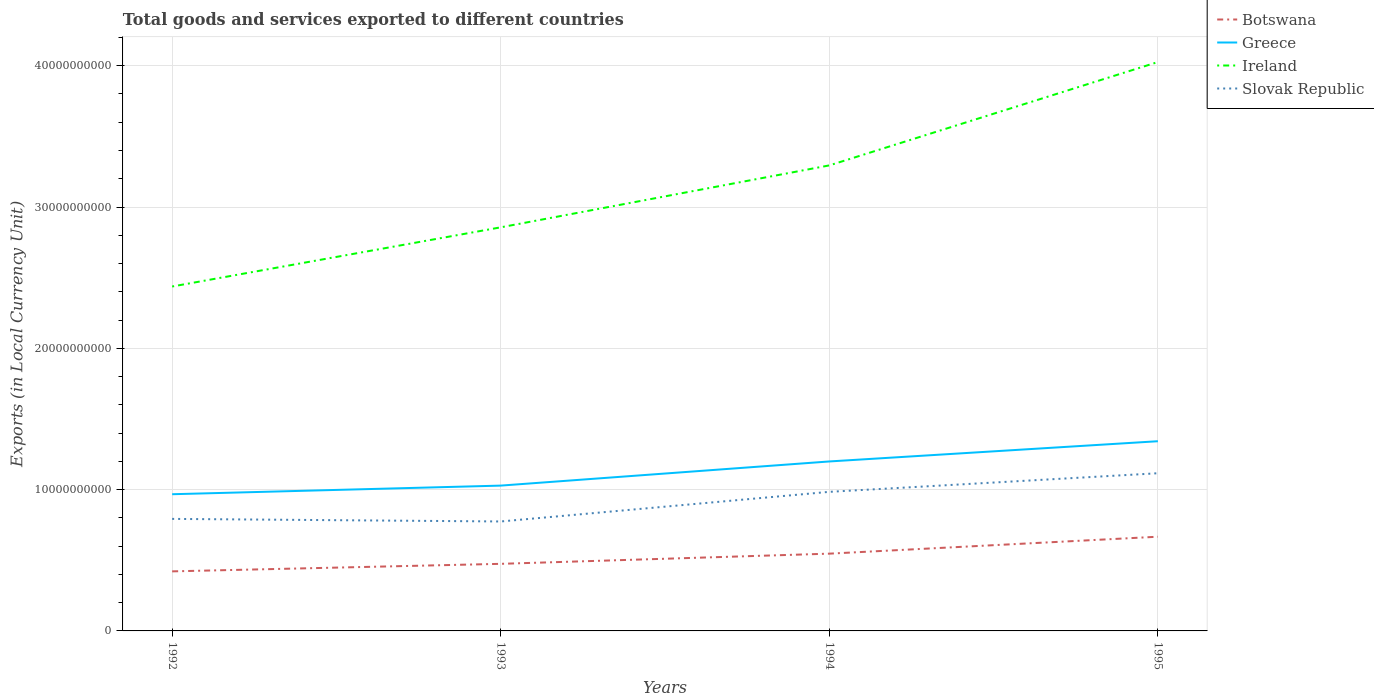Does the line corresponding to Greece intersect with the line corresponding to Slovak Republic?
Offer a very short reply. No. Is the number of lines equal to the number of legend labels?
Provide a succinct answer. Yes. Across all years, what is the maximum Amount of goods and services exports in Ireland?
Offer a very short reply. 2.44e+1. In which year was the Amount of goods and services exports in Ireland maximum?
Your response must be concise. 1992. What is the total Amount of goods and services exports in Ireland in the graph?
Your answer should be compact. -7.31e+09. What is the difference between the highest and the second highest Amount of goods and services exports in Ireland?
Make the answer very short. 1.59e+1. How many lines are there?
Give a very brief answer. 4. What is the difference between two consecutive major ticks on the Y-axis?
Offer a terse response. 1.00e+1. Are the values on the major ticks of Y-axis written in scientific E-notation?
Your answer should be very brief. No. Does the graph contain any zero values?
Your answer should be very brief. No. Where does the legend appear in the graph?
Offer a terse response. Top right. How many legend labels are there?
Offer a very short reply. 4. How are the legend labels stacked?
Offer a very short reply. Vertical. What is the title of the graph?
Offer a terse response. Total goods and services exported to different countries. What is the label or title of the X-axis?
Provide a succinct answer. Years. What is the label or title of the Y-axis?
Your answer should be compact. Exports (in Local Currency Unit). What is the Exports (in Local Currency Unit) in Botswana in 1992?
Provide a succinct answer. 4.21e+09. What is the Exports (in Local Currency Unit) in Greece in 1992?
Provide a short and direct response. 9.67e+09. What is the Exports (in Local Currency Unit) in Ireland in 1992?
Make the answer very short. 2.44e+1. What is the Exports (in Local Currency Unit) of Slovak Republic in 1992?
Provide a succinct answer. 7.93e+09. What is the Exports (in Local Currency Unit) of Botswana in 1993?
Offer a terse response. 4.75e+09. What is the Exports (in Local Currency Unit) of Greece in 1993?
Offer a very short reply. 1.03e+1. What is the Exports (in Local Currency Unit) in Ireland in 1993?
Ensure brevity in your answer.  2.86e+1. What is the Exports (in Local Currency Unit) in Slovak Republic in 1993?
Provide a short and direct response. 7.75e+09. What is the Exports (in Local Currency Unit) of Botswana in 1994?
Your response must be concise. 5.47e+09. What is the Exports (in Local Currency Unit) of Greece in 1994?
Your response must be concise. 1.20e+1. What is the Exports (in Local Currency Unit) in Ireland in 1994?
Your response must be concise. 3.29e+1. What is the Exports (in Local Currency Unit) of Slovak Republic in 1994?
Keep it short and to the point. 9.84e+09. What is the Exports (in Local Currency Unit) of Botswana in 1995?
Offer a very short reply. 6.67e+09. What is the Exports (in Local Currency Unit) of Greece in 1995?
Ensure brevity in your answer.  1.34e+1. What is the Exports (in Local Currency Unit) of Ireland in 1995?
Provide a short and direct response. 4.03e+1. What is the Exports (in Local Currency Unit) in Slovak Republic in 1995?
Your response must be concise. 1.12e+1. Across all years, what is the maximum Exports (in Local Currency Unit) in Botswana?
Ensure brevity in your answer.  6.67e+09. Across all years, what is the maximum Exports (in Local Currency Unit) of Greece?
Provide a short and direct response. 1.34e+1. Across all years, what is the maximum Exports (in Local Currency Unit) of Ireland?
Keep it short and to the point. 4.03e+1. Across all years, what is the maximum Exports (in Local Currency Unit) of Slovak Republic?
Your response must be concise. 1.12e+1. Across all years, what is the minimum Exports (in Local Currency Unit) in Botswana?
Make the answer very short. 4.21e+09. Across all years, what is the minimum Exports (in Local Currency Unit) of Greece?
Provide a succinct answer. 9.67e+09. Across all years, what is the minimum Exports (in Local Currency Unit) in Ireland?
Keep it short and to the point. 2.44e+1. Across all years, what is the minimum Exports (in Local Currency Unit) in Slovak Republic?
Keep it short and to the point. 7.75e+09. What is the total Exports (in Local Currency Unit) in Botswana in the graph?
Ensure brevity in your answer.  2.11e+1. What is the total Exports (in Local Currency Unit) in Greece in the graph?
Your answer should be compact. 4.54e+1. What is the total Exports (in Local Currency Unit) of Ireland in the graph?
Your answer should be very brief. 1.26e+11. What is the total Exports (in Local Currency Unit) in Slovak Republic in the graph?
Your response must be concise. 3.67e+1. What is the difference between the Exports (in Local Currency Unit) of Botswana in 1992 and that in 1993?
Your answer should be very brief. -5.33e+08. What is the difference between the Exports (in Local Currency Unit) in Greece in 1992 and that in 1993?
Provide a succinct answer. -6.10e+08. What is the difference between the Exports (in Local Currency Unit) in Ireland in 1992 and that in 1993?
Your answer should be very brief. -4.19e+09. What is the difference between the Exports (in Local Currency Unit) of Slovak Republic in 1992 and that in 1993?
Your answer should be compact. 1.83e+08. What is the difference between the Exports (in Local Currency Unit) of Botswana in 1992 and that in 1994?
Your answer should be very brief. -1.25e+09. What is the difference between the Exports (in Local Currency Unit) of Greece in 1992 and that in 1994?
Keep it short and to the point. -2.32e+09. What is the difference between the Exports (in Local Currency Unit) in Ireland in 1992 and that in 1994?
Offer a very short reply. -8.57e+09. What is the difference between the Exports (in Local Currency Unit) in Slovak Republic in 1992 and that in 1994?
Provide a short and direct response. -1.91e+09. What is the difference between the Exports (in Local Currency Unit) of Botswana in 1992 and that in 1995?
Give a very brief answer. -2.45e+09. What is the difference between the Exports (in Local Currency Unit) in Greece in 1992 and that in 1995?
Provide a short and direct response. -3.75e+09. What is the difference between the Exports (in Local Currency Unit) in Ireland in 1992 and that in 1995?
Ensure brevity in your answer.  -1.59e+1. What is the difference between the Exports (in Local Currency Unit) of Slovak Republic in 1992 and that in 1995?
Your response must be concise. -3.23e+09. What is the difference between the Exports (in Local Currency Unit) in Botswana in 1993 and that in 1994?
Offer a very short reply. -7.21e+08. What is the difference between the Exports (in Local Currency Unit) of Greece in 1993 and that in 1994?
Make the answer very short. -1.71e+09. What is the difference between the Exports (in Local Currency Unit) in Ireland in 1993 and that in 1994?
Your response must be concise. -4.38e+09. What is the difference between the Exports (in Local Currency Unit) of Slovak Republic in 1993 and that in 1994?
Your response must be concise. -2.10e+09. What is the difference between the Exports (in Local Currency Unit) of Botswana in 1993 and that in 1995?
Offer a terse response. -1.92e+09. What is the difference between the Exports (in Local Currency Unit) in Greece in 1993 and that in 1995?
Provide a succinct answer. -3.14e+09. What is the difference between the Exports (in Local Currency Unit) of Ireland in 1993 and that in 1995?
Your answer should be compact. -1.17e+1. What is the difference between the Exports (in Local Currency Unit) of Slovak Republic in 1993 and that in 1995?
Make the answer very short. -3.41e+09. What is the difference between the Exports (in Local Currency Unit) in Botswana in 1994 and that in 1995?
Provide a succinct answer. -1.20e+09. What is the difference between the Exports (in Local Currency Unit) in Greece in 1994 and that in 1995?
Your answer should be very brief. -1.43e+09. What is the difference between the Exports (in Local Currency Unit) of Ireland in 1994 and that in 1995?
Keep it short and to the point. -7.31e+09. What is the difference between the Exports (in Local Currency Unit) in Slovak Republic in 1994 and that in 1995?
Provide a succinct answer. -1.32e+09. What is the difference between the Exports (in Local Currency Unit) in Botswana in 1992 and the Exports (in Local Currency Unit) in Greece in 1993?
Ensure brevity in your answer.  -6.07e+09. What is the difference between the Exports (in Local Currency Unit) of Botswana in 1992 and the Exports (in Local Currency Unit) of Ireland in 1993?
Provide a short and direct response. -2.43e+1. What is the difference between the Exports (in Local Currency Unit) of Botswana in 1992 and the Exports (in Local Currency Unit) of Slovak Republic in 1993?
Your response must be concise. -3.53e+09. What is the difference between the Exports (in Local Currency Unit) of Greece in 1992 and the Exports (in Local Currency Unit) of Ireland in 1993?
Give a very brief answer. -1.89e+1. What is the difference between the Exports (in Local Currency Unit) of Greece in 1992 and the Exports (in Local Currency Unit) of Slovak Republic in 1993?
Keep it short and to the point. 1.93e+09. What is the difference between the Exports (in Local Currency Unit) of Ireland in 1992 and the Exports (in Local Currency Unit) of Slovak Republic in 1993?
Your response must be concise. 1.66e+1. What is the difference between the Exports (in Local Currency Unit) of Botswana in 1992 and the Exports (in Local Currency Unit) of Greece in 1994?
Ensure brevity in your answer.  -7.78e+09. What is the difference between the Exports (in Local Currency Unit) of Botswana in 1992 and the Exports (in Local Currency Unit) of Ireland in 1994?
Your response must be concise. -2.87e+1. What is the difference between the Exports (in Local Currency Unit) in Botswana in 1992 and the Exports (in Local Currency Unit) in Slovak Republic in 1994?
Provide a succinct answer. -5.63e+09. What is the difference between the Exports (in Local Currency Unit) in Greece in 1992 and the Exports (in Local Currency Unit) in Ireland in 1994?
Offer a very short reply. -2.33e+1. What is the difference between the Exports (in Local Currency Unit) of Greece in 1992 and the Exports (in Local Currency Unit) of Slovak Republic in 1994?
Your answer should be very brief. -1.69e+08. What is the difference between the Exports (in Local Currency Unit) of Ireland in 1992 and the Exports (in Local Currency Unit) of Slovak Republic in 1994?
Make the answer very short. 1.45e+1. What is the difference between the Exports (in Local Currency Unit) of Botswana in 1992 and the Exports (in Local Currency Unit) of Greece in 1995?
Provide a short and direct response. -9.21e+09. What is the difference between the Exports (in Local Currency Unit) in Botswana in 1992 and the Exports (in Local Currency Unit) in Ireland in 1995?
Give a very brief answer. -3.60e+1. What is the difference between the Exports (in Local Currency Unit) in Botswana in 1992 and the Exports (in Local Currency Unit) in Slovak Republic in 1995?
Offer a very short reply. -6.94e+09. What is the difference between the Exports (in Local Currency Unit) in Greece in 1992 and the Exports (in Local Currency Unit) in Ireland in 1995?
Ensure brevity in your answer.  -3.06e+1. What is the difference between the Exports (in Local Currency Unit) in Greece in 1992 and the Exports (in Local Currency Unit) in Slovak Republic in 1995?
Your answer should be compact. -1.49e+09. What is the difference between the Exports (in Local Currency Unit) in Ireland in 1992 and the Exports (in Local Currency Unit) in Slovak Republic in 1995?
Ensure brevity in your answer.  1.32e+1. What is the difference between the Exports (in Local Currency Unit) in Botswana in 1993 and the Exports (in Local Currency Unit) in Greece in 1994?
Provide a short and direct response. -7.25e+09. What is the difference between the Exports (in Local Currency Unit) in Botswana in 1993 and the Exports (in Local Currency Unit) in Ireland in 1994?
Give a very brief answer. -2.82e+1. What is the difference between the Exports (in Local Currency Unit) of Botswana in 1993 and the Exports (in Local Currency Unit) of Slovak Republic in 1994?
Provide a succinct answer. -5.10e+09. What is the difference between the Exports (in Local Currency Unit) in Greece in 1993 and the Exports (in Local Currency Unit) in Ireland in 1994?
Your answer should be compact. -2.27e+1. What is the difference between the Exports (in Local Currency Unit) in Greece in 1993 and the Exports (in Local Currency Unit) in Slovak Republic in 1994?
Make the answer very short. 4.41e+08. What is the difference between the Exports (in Local Currency Unit) of Ireland in 1993 and the Exports (in Local Currency Unit) of Slovak Republic in 1994?
Your response must be concise. 1.87e+1. What is the difference between the Exports (in Local Currency Unit) in Botswana in 1993 and the Exports (in Local Currency Unit) in Greece in 1995?
Your answer should be very brief. -8.68e+09. What is the difference between the Exports (in Local Currency Unit) in Botswana in 1993 and the Exports (in Local Currency Unit) in Ireland in 1995?
Provide a short and direct response. -3.55e+1. What is the difference between the Exports (in Local Currency Unit) in Botswana in 1993 and the Exports (in Local Currency Unit) in Slovak Republic in 1995?
Make the answer very short. -6.41e+09. What is the difference between the Exports (in Local Currency Unit) in Greece in 1993 and the Exports (in Local Currency Unit) in Ireland in 1995?
Your response must be concise. -3.00e+1. What is the difference between the Exports (in Local Currency Unit) in Greece in 1993 and the Exports (in Local Currency Unit) in Slovak Republic in 1995?
Your answer should be very brief. -8.75e+08. What is the difference between the Exports (in Local Currency Unit) of Ireland in 1993 and the Exports (in Local Currency Unit) of Slovak Republic in 1995?
Provide a succinct answer. 1.74e+1. What is the difference between the Exports (in Local Currency Unit) of Botswana in 1994 and the Exports (in Local Currency Unit) of Greece in 1995?
Make the answer very short. -7.96e+09. What is the difference between the Exports (in Local Currency Unit) of Botswana in 1994 and the Exports (in Local Currency Unit) of Ireland in 1995?
Offer a very short reply. -3.48e+1. What is the difference between the Exports (in Local Currency Unit) of Botswana in 1994 and the Exports (in Local Currency Unit) of Slovak Republic in 1995?
Keep it short and to the point. -5.69e+09. What is the difference between the Exports (in Local Currency Unit) in Greece in 1994 and the Exports (in Local Currency Unit) in Ireland in 1995?
Offer a very short reply. -2.83e+1. What is the difference between the Exports (in Local Currency Unit) in Greece in 1994 and the Exports (in Local Currency Unit) in Slovak Republic in 1995?
Provide a short and direct response. 8.34e+08. What is the difference between the Exports (in Local Currency Unit) of Ireland in 1994 and the Exports (in Local Currency Unit) of Slovak Republic in 1995?
Make the answer very short. 2.18e+1. What is the average Exports (in Local Currency Unit) of Botswana per year?
Ensure brevity in your answer.  5.27e+09. What is the average Exports (in Local Currency Unit) of Greece per year?
Your response must be concise. 1.13e+1. What is the average Exports (in Local Currency Unit) of Ireland per year?
Offer a terse response. 3.15e+1. What is the average Exports (in Local Currency Unit) in Slovak Republic per year?
Your answer should be compact. 9.17e+09. In the year 1992, what is the difference between the Exports (in Local Currency Unit) in Botswana and Exports (in Local Currency Unit) in Greece?
Offer a very short reply. -5.46e+09. In the year 1992, what is the difference between the Exports (in Local Currency Unit) of Botswana and Exports (in Local Currency Unit) of Ireland?
Offer a very short reply. -2.02e+1. In the year 1992, what is the difference between the Exports (in Local Currency Unit) of Botswana and Exports (in Local Currency Unit) of Slovak Republic?
Provide a short and direct response. -3.71e+09. In the year 1992, what is the difference between the Exports (in Local Currency Unit) in Greece and Exports (in Local Currency Unit) in Ireland?
Your answer should be very brief. -1.47e+1. In the year 1992, what is the difference between the Exports (in Local Currency Unit) in Greece and Exports (in Local Currency Unit) in Slovak Republic?
Your answer should be compact. 1.75e+09. In the year 1992, what is the difference between the Exports (in Local Currency Unit) in Ireland and Exports (in Local Currency Unit) in Slovak Republic?
Make the answer very short. 1.64e+1. In the year 1993, what is the difference between the Exports (in Local Currency Unit) of Botswana and Exports (in Local Currency Unit) of Greece?
Keep it short and to the point. -5.54e+09. In the year 1993, what is the difference between the Exports (in Local Currency Unit) in Botswana and Exports (in Local Currency Unit) in Ireland?
Keep it short and to the point. -2.38e+1. In the year 1993, what is the difference between the Exports (in Local Currency Unit) of Botswana and Exports (in Local Currency Unit) of Slovak Republic?
Your response must be concise. -3.00e+09. In the year 1993, what is the difference between the Exports (in Local Currency Unit) of Greece and Exports (in Local Currency Unit) of Ireland?
Give a very brief answer. -1.83e+1. In the year 1993, what is the difference between the Exports (in Local Currency Unit) of Greece and Exports (in Local Currency Unit) of Slovak Republic?
Provide a succinct answer. 2.54e+09. In the year 1993, what is the difference between the Exports (in Local Currency Unit) of Ireland and Exports (in Local Currency Unit) of Slovak Republic?
Your response must be concise. 2.08e+1. In the year 1994, what is the difference between the Exports (in Local Currency Unit) in Botswana and Exports (in Local Currency Unit) in Greece?
Make the answer very short. -6.52e+09. In the year 1994, what is the difference between the Exports (in Local Currency Unit) of Botswana and Exports (in Local Currency Unit) of Ireland?
Your response must be concise. -2.75e+1. In the year 1994, what is the difference between the Exports (in Local Currency Unit) in Botswana and Exports (in Local Currency Unit) in Slovak Republic?
Provide a succinct answer. -4.37e+09. In the year 1994, what is the difference between the Exports (in Local Currency Unit) of Greece and Exports (in Local Currency Unit) of Ireland?
Offer a very short reply. -2.10e+1. In the year 1994, what is the difference between the Exports (in Local Currency Unit) in Greece and Exports (in Local Currency Unit) in Slovak Republic?
Keep it short and to the point. 2.15e+09. In the year 1994, what is the difference between the Exports (in Local Currency Unit) of Ireland and Exports (in Local Currency Unit) of Slovak Republic?
Provide a short and direct response. 2.31e+1. In the year 1995, what is the difference between the Exports (in Local Currency Unit) of Botswana and Exports (in Local Currency Unit) of Greece?
Provide a succinct answer. -6.76e+09. In the year 1995, what is the difference between the Exports (in Local Currency Unit) in Botswana and Exports (in Local Currency Unit) in Ireland?
Make the answer very short. -3.36e+1. In the year 1995, what is the difference between the Exports (in Local Currency Unit) in Botswana and Exports (in Local Currency Unit) in Slovak Republic?
Make the answer very short. -4.49e+09. In the year 1995, what is the difference between the Exports (in Local Currency Unit) of Greece and Exports (in Local Currency Unit) of Ireland?
Your response must be concise. -2.68e+1. In the year 1995, what is the difference between the Exports (in Local Currency Unit) in Greece and Exports (in Local Currency Unit) in Slovak Republic?
Provide a succinct answer. 2.27e+09. In the year 1995, what is the difference between the Exports (in Local Currency Unit) in Ireland and Exports (in Local Currency Unit) in Slovak Republic?
Keep it short and to the point. 2.91e+1. What is the ratio of the Exports (in Local Currency Unit) of Botswana in 1992 to that in 1993?
Offer a very short reply. 0.89. What is the ratio of the Exports (in Local Currency Unit) of Greece in 1992 to that in 1993?
Provide a short and direct response. 0.94. What is the ratio of the Exports (in Local Currency Unit) in Ireland in 1992 to that in 1993?
Your response must be concise. 0.85. What is the ratio of the Exports (in Local Currency Unit) in Slovak Republic in 1992 to that in 1993?
Make the answer very short. 1.02. What is the ratio of the Exports (in Local Currency Unit) in Botswana in 1992 to that in 1994?
Offer a terse response. 0.77. What is the ratio of the Exports (in Local Currency Unit) in Greece in 1992 to that in 1994?
Offer a very short reply. 0.81. What is the ratio of the Exports (in Local Currency Unit) in Ireland in 1992 to that in 1994?
Your response must be concise. 0.74. What is the ratio of the Exports (in Local Currency Unit) of Slovak Republic in 1992 to that in 1994?
Ensure brevity in your answer.  0.81. What is the ratio of the Exports (in Local Currency Unit) in Botswana in 1992 to that in 1995?
Ensure brevity in your answer.  0.63. What is the ratio of the Exports (in Local Currency Unit) of Greece in 1992 to that in 1995?
Your answer should be very brief. 0.72. What is the ratio of the Exports (in Local Currency Unit) of Ireland in 1992 to that in 1995?
Ensure brevity in your answer.  0.61. What is the ratio of the Exports (in Local Currency Unit) of Slovak Republic in 1992 to that in 1995?
Your answer should be compact. 0.71. What is the ratio of the Exports (in Local Currency Unit) in Botswana in 1993 to that in 1994?
Offer a very short reply. 0.87. What is the ratio of the Exports (in Local Currency Unit) of Greece in 1993 to that in 1994?
Offer a very short reply. 0.86. What is the ratio of the Exports (in Local Currency Unit) in Ireland in 1993 to that in 1994?
Your response must be concise. 0.87. What is the ratio of the Exports (in Local Currency Unit) of Slovak Republic in 1993 to that in 1994?
Offer a terse response. 0.79. What is the ratio of the Exports (in Local Currency Unit) in Botswana in 1993 to that in 1995?
Your response must be concise. 0.71. What is the ratio of the Exports (in Local Currency Unit) of Greece in 1993 to that in 1995?
Your answer should be compact. 0.77. What is the ratio of the Exports (in Local Currency Unit) of Ireland in 1993 to that in 1995?
Offer a very short reply. 0.71. What is the ratio of the Exports (in Local Currency Unit) of Slovak Republic in 1993 to that in 1995?
Provide a short and direct response. 0.69. What is the ratio of the Exports (in Local Currency Unit) in Botswana in 1994 to that in 1995?
Your answer should be compact. 0.82. What is the ratio of the Exports (in Local Currency Unit) of Greece in 1994 to that in 1995?
Give a very brief answer. 0.89. What is the ratio of the Exports (in Local Currency Unit) of Ireland in 1994 to that in 1995?
Your answer should be very brief. 0.82. What is the ratio of the Exports (in Local Currency Unit) in Slovak Republic in 1994 to that in 1995?
Your answer should be compact. 0.88. What is the difference between the highest and the second highest Exports (in Local Currency Unit) in Botswana?
Your answer should be compact. 1.20e+09. What is the difference between the highest and the second highest Exports (in Local Currency Unit) in Greece?
Provide a succinct answer. 1.43e+09. What is the difference between the highest and the second highest Exports (in Local Currency Unit) of Ireland?
Your answer should be very brief. 7.31e+09. What is the difference between the highest and the second highest Exports (in Local Currency Unit) of Slovak Republic?
Make the answer very short. 1.32e+09. What is the difference between the highest and the lowest Exports (in Local Currency Unit) in Botswana?
Make the answer very short. 2.45e+09. What is the difference between the highest and the lowest Exports (in Local Currency Unit) of Greece?
Provide a succinct answer. 3.75e+09. What is the difference between the highest and the lowest Exports (in Local Currency Unit) of Ireland?
Ensure brevity in your answer.  1.59e+1. What is the difference between the highest and the lowest Exports (in Local Currency Unit) of Slovak Republic?
Make the answer very short. 3.41e+09. 